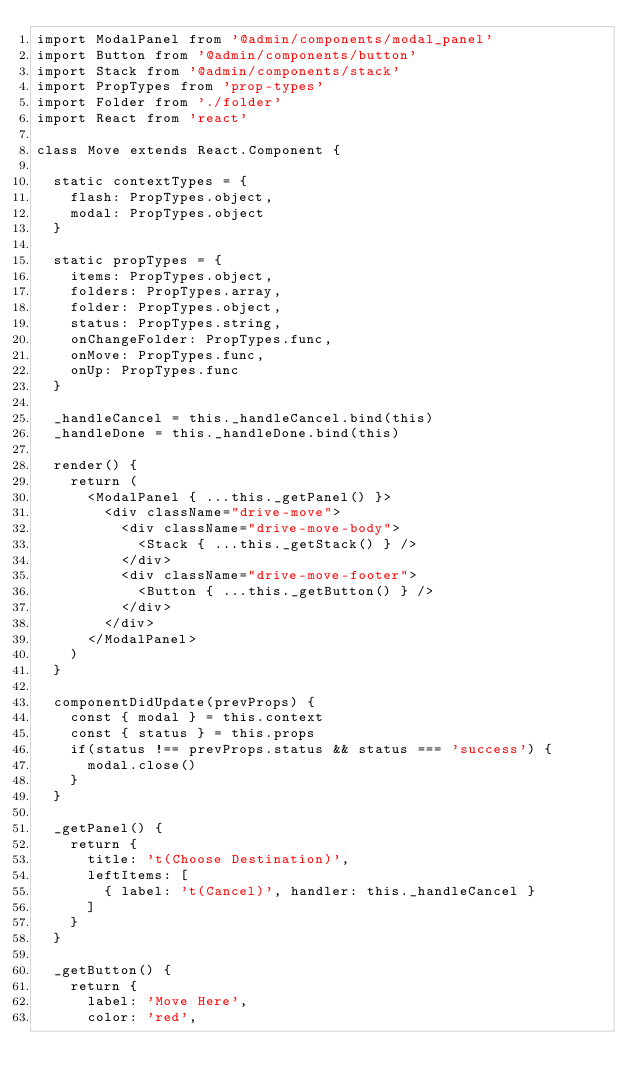<code> <loc_0><loc_0><loc_500><loc_500><_JavaScript_>import ModalPanel from '@admin/components/modal_panel'
import Button from '@admin/components/button'
import Stack from '@admin/components/stack'
import PropTypes from 'prop-types'
import Folder from './folder'
import React from 'react'

class Move extends React.Component {

  static contextTypes = {
    flash: PropTypes.object,
    modal: PropTypes.object
  }

  static propTypes = {
    items: PropTypes.object,
    folders: PropTypes.array,
    folder: PropTypes.object,
    status: PropTypes.string,
    onChangeFolder: PropTypes.func,
    onMove: PropTypes.func,
    onUp: PropTypes.func
  }

  _handleCancel = this._handleCancel.bind(this)
  _handleDone = this._handleDone.bind(this)

  render() {
    return (
      <ModalPanel { ...this._getPanel() }>
        <div className="drive-move">
          <div className="drive-move-body">
            <Stack { ...this._getStack() } />
          </div>
          <div className="drive-move-footer">
            <Button { ...this._getButton() } />
          </div>
        </div>
      </ModalPanel>
    )
  }

  componentDidUpdate(prevProps) {
    const { modal } = this.context
    const { status } = this.props
    if(status !== prevProps.status && status === 'success') {
      modal.close()
    }
  }

  _getPanel() {
    return {
      title: 't(Choose Destination)',
      leftItems: [
        { label: 't(Cancel)', handler: this._handleCancel }
      ]
    }
  }

  _getButton() {
    return {
      label: 'Move Here',
      color: 'red',</code> 